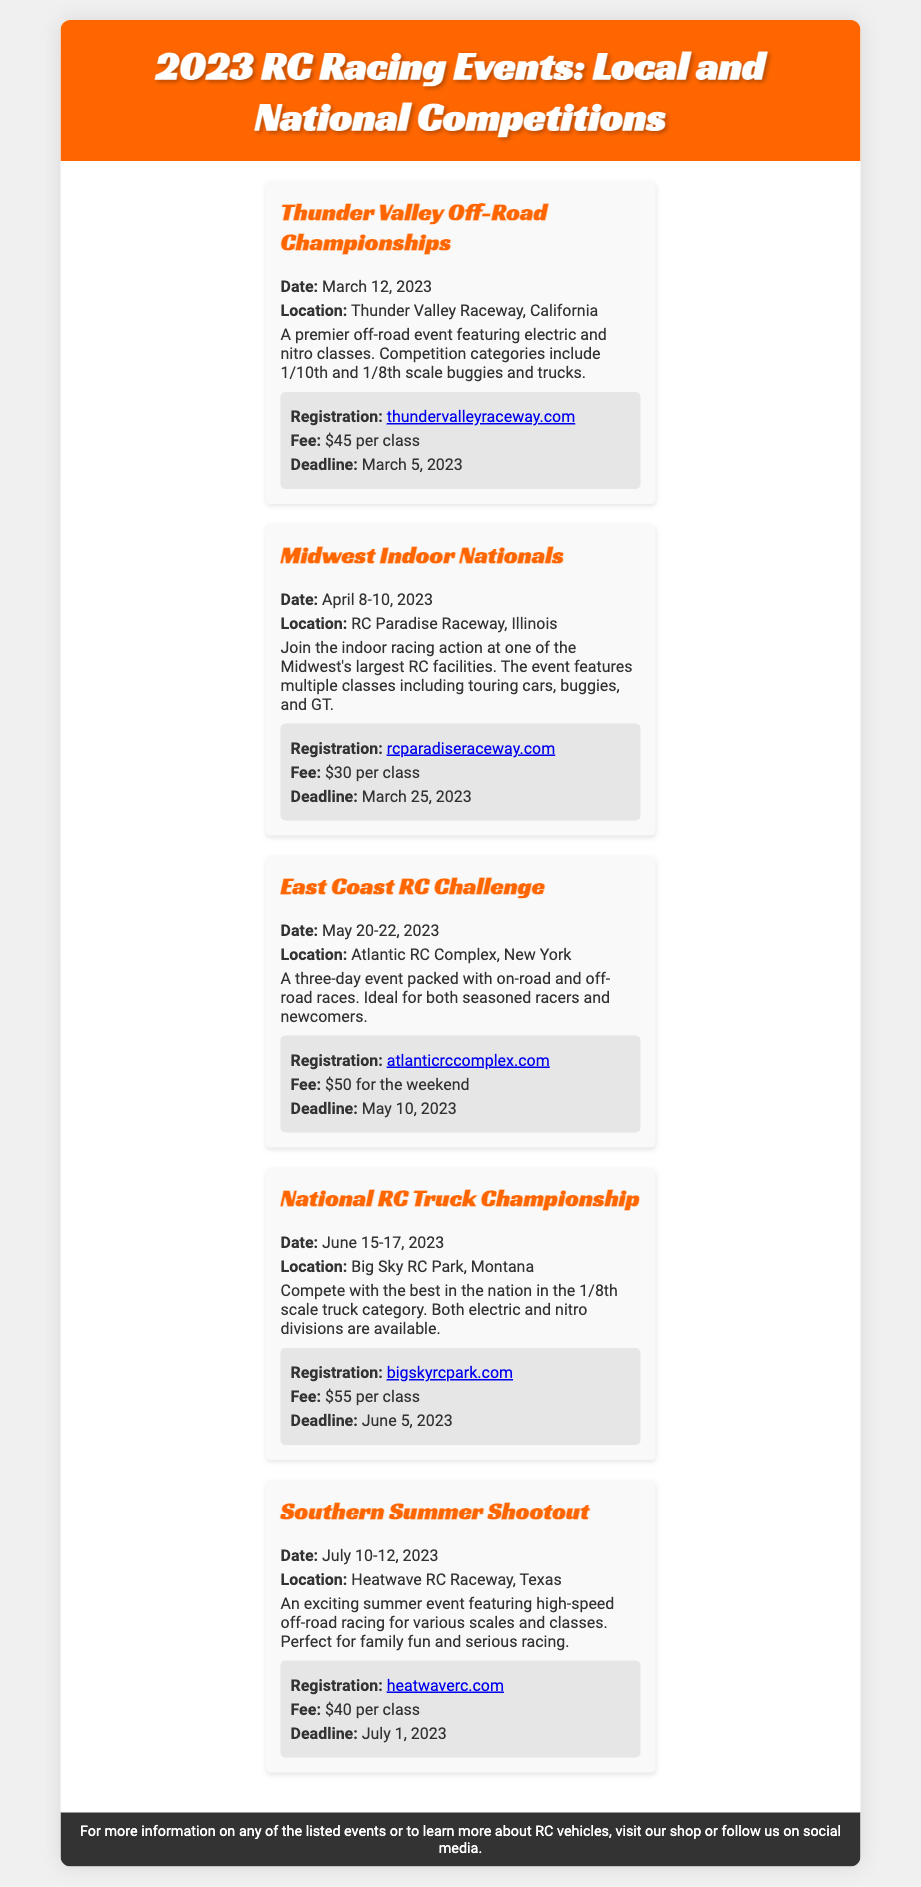What is the date of the Thunder Valley Off-Road Championships? The date is explicitly stated in the event details for the Thunder Valley Off-Road Championships as March 12, 2023.
Answer: March 12, 2023 Where is the Midwest Indoor Nationals taking place? The location of the Midwest Indoor Nationals is specified in the event details as RC Paradise Raceway, Illinois.
Answer: RC Paradise Raceway, Illinois What is the registration fee for the National RC Truck Championship? The fee for registration is listed in the event details as $55 per class for the National RC Truck Championship.
Answer: $55 per class What is the deadline for registration for the Southern Summer Shootout? The deadline for registration is noted in the event details as July 1, 2023 for the Southern Summer Shootout.
Answer: July 1, 2023 What types of vehicles can compete in the East Coast RC Challenge? The types of vehicles for the East Coast RC Challenge include on-road and off-road vehicles as mentioned in the event description.
Answer: On-road and off-road How many classes are offered in the Thunder Valley Off-Road Championships? The competition categories for the Thunder Valley Off-Road Championships include 1/10th and 1/8th scale buggies and trucks, indicating at least two classes.
Answer: At least two classes What is the main theme of the events listed in this document? The events primarily focus on various RC racing competitions, including off-road and on-road races.
Answer: RC racing competitions How long does the East Coast RC Challenge last? The duration of the East Coast RC Challenge is mentioned as three days, indicating from May 20 to May 22, 2023.
Answer: Three days 